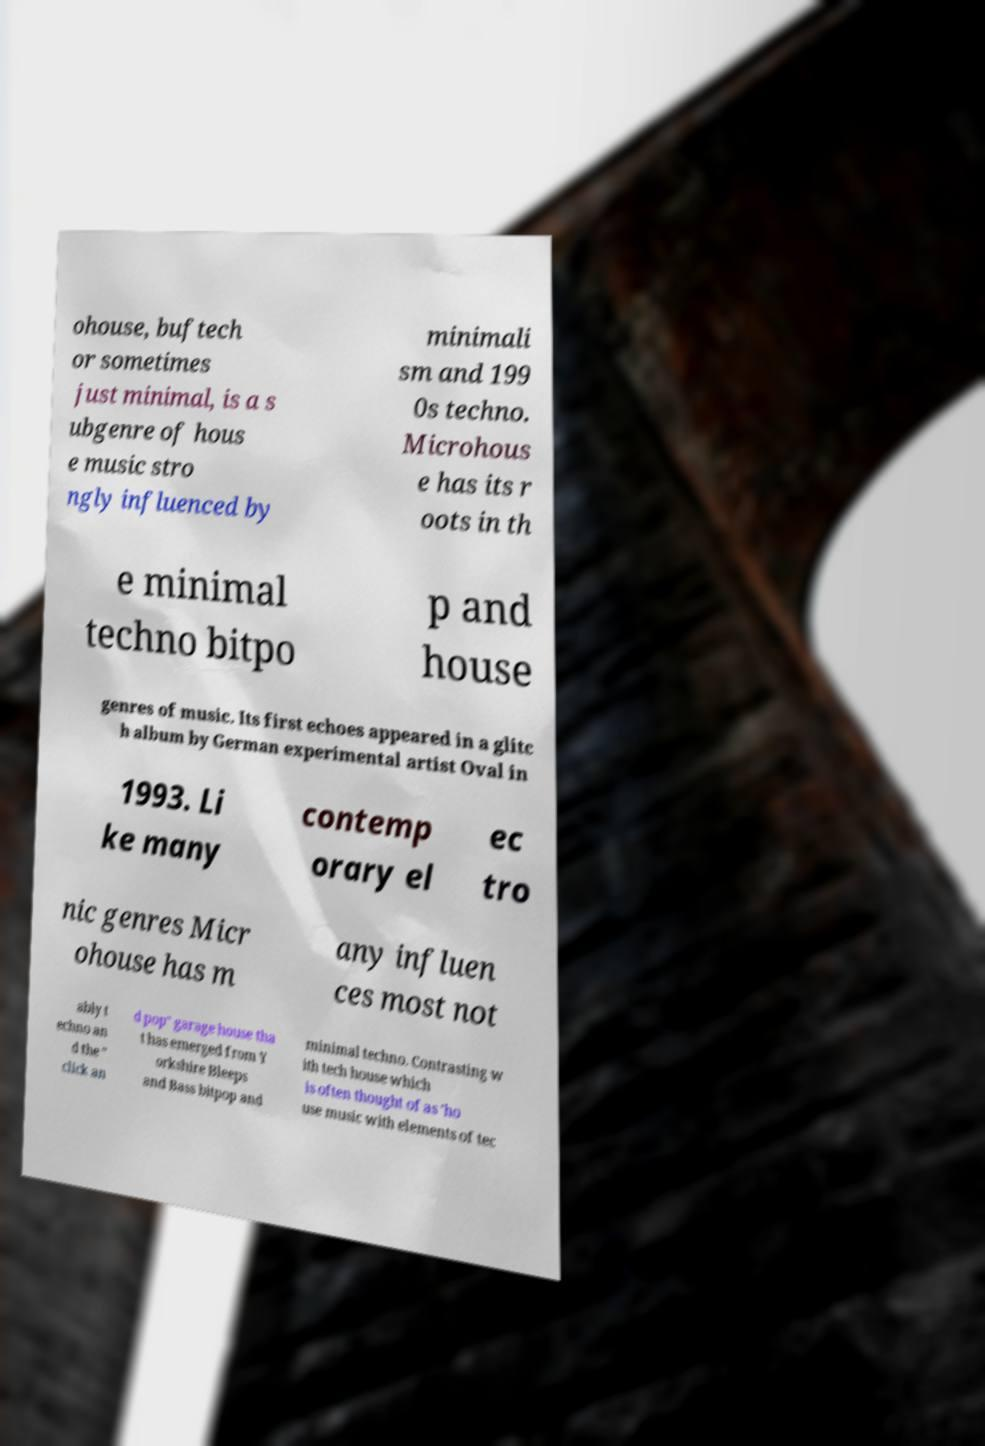What messages or text are displayed in this image? I need them in a readable, typed format. ohouse, buftech or sometimes just minimal, is a s ubgenre of hous e music stro ngly influenced by minimali sm and 199 0s techno. Microhous e has its r oots in th e minimal techno bitpo p and house genres of music. Its first echoes appeared in a glitc h album by German experimental artist Oval in 1993. Li ke many contemp orary el ec tro nic genres Micr ohouse has m any influen ces most not ably t echno an d the " click an d pop" garage house tha t has emerged from Y orkshire Bleeps and Bass bitpop and minimal techno. Contrasting w ith tech house which is often thought of as 'ho use music with elements of tec 